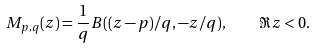Convert formula to latex. <formula><loc_0><loc_0><loc_500><loc_500>M _ { p , q } ( z ) = \frac { 1 } { q } B ( ( z - p ) / q , - z / q ) , \quad \Re z < 0 .</formula> 